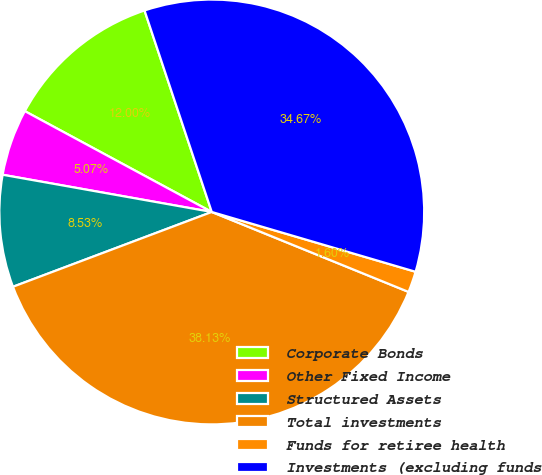Convert chart. <chart><loc_0><loc_0><loc_500><loc_500><pie_chart><fcel>Corporate Bonds<fcel>Other Fixed Income<fcel>Structured Assets<fcel>Total investments<fcel>Funds for retiree health<fcel>Investments (excluding funds<nl><fcel>12.0%<fcel>5.07%<fcel>8.53%<fcel>38.13%<fcel>1.6%<fcel>34.67%<nl></chart> 